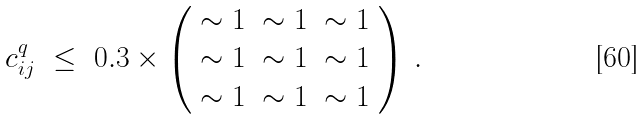Convert formula to latex. <formula><loc_0><loc_0><loc_500><loc_500>c ^ { q } _ { i j } \ \leq \ 0 . 3 \times \left ( \begin{array} { c c c } \sim 1 & \sim 1 & \sim 1 \\ \sim 1 & \sim 1 & \sim 1 \\ \sim 1 & \sim 1 & \sim 1 \end{array} \right ) \, .</formula> 